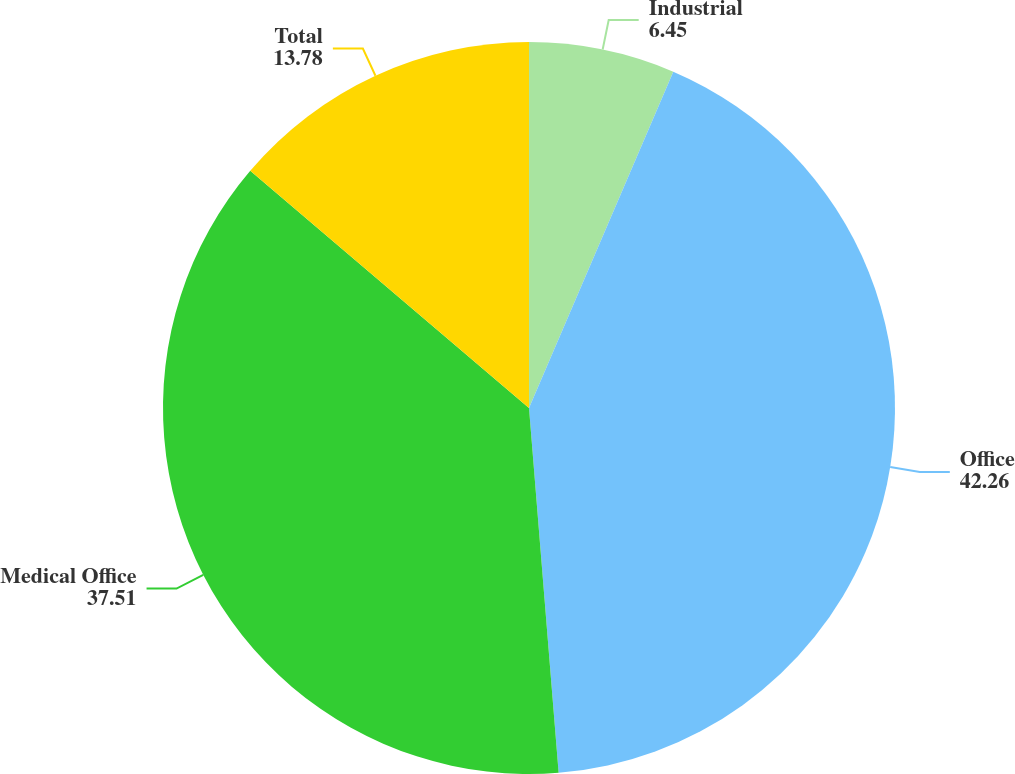Convert chart to OTSL. <chart><loc_0><loc_0><loc_500><loc_500><pie_chart><fcel>Industrial<fcel>Office<fcel>Medical Office<fcel>Total<nl><fcel>6.45%<fcel>42.26%<fcel>37.51%<fcel>13.78%<nl></chart> 